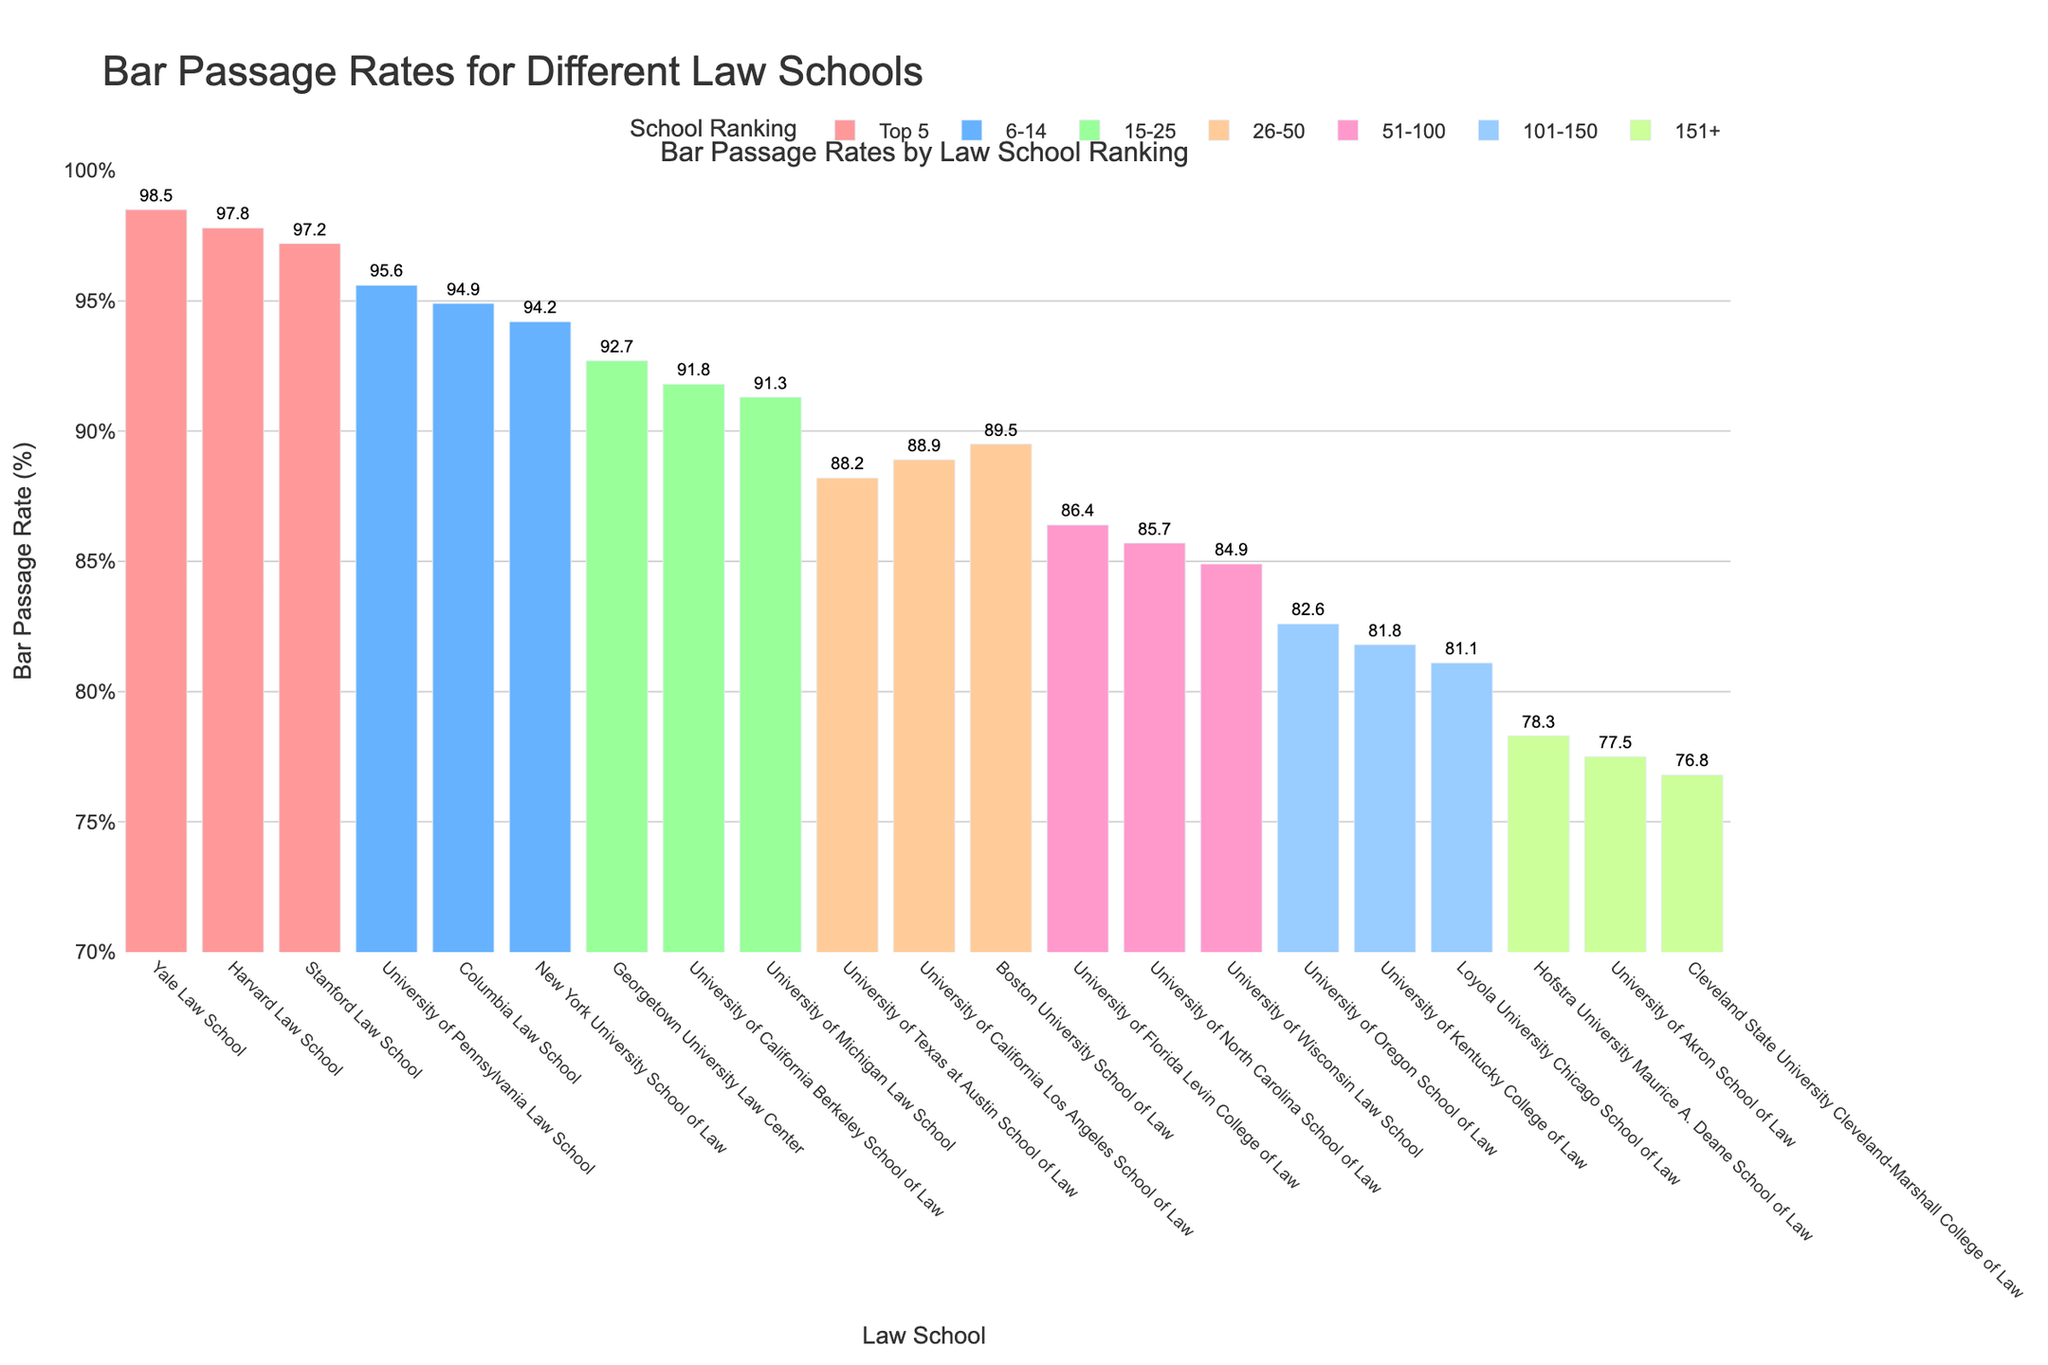What's the range of bar passage rates for law schools ranked in the Top 5? To find the range, we subtract the smallest bar passage rate in the Top 5 from the largest one. The rates are 98.5 (Yale), 97.8 (Harvard), and 97.2 (Stanford). The range is 98.5 - 97.2 = 1.3
Answer: 1.3 Which school has the highest bar passage rate in the 26-50 ranking category? We compare the bar passage rates within the 26-50 category: Boston University (89.5), UCLA (88.9), and University of Texas at Austin (88.2). Boston University has the highest rate.
Answer: Boston University School of Law How much greater is Yale Law School's bar passage rate compared to Cleveland State University? Yale's rate is 98.5% and Cleveland State University's rate is 76.8%. The difference is 98.5 - 76.8 = 21.7
Answer: 21.7 What is the average bar passage rate for law schools ranked 6-14? The rates are University of Pennsylvania (95.6), Columbia (94.9), and NYU (94.2). Summing these: 95.6 + 94.9 + 94.2 = 284.7, and the average is 284.7 / 3 = 94.9
Answer: 94.9 Which color represents the schools ranked 151+ in the figure? By visual inspection, the color for the 151+ category is the last color applied in the series. The bar colors follow the order of the categories: '#FF9999' for Top 5, etc. The last color in the sequence is green, represented by '#CCFF99'.
Answer: Green How many schools have a bar passage rate below 90%? By scanning through all the bars, the schools with rates below 90% are University of Texas at Austin, University of Florida Levin, University of North Carolina, University of Wisconsin, University of Oregon, University of Kentucky, Loyola University Chicago, Hofstra, University of Akron, and Cleveland State University. Thus, there are 10 schools.
Answer: 10 What is the median bar passage rate for schools ranked 101-150? The rates are University of Oregon (82.6), University of Kentucky (81.8), and Loyola University Chicago (81.1). Arranged in order: 81.1, 81.8, 82.6. The median value is the middle one, 81.8.
Answer: 81.8 